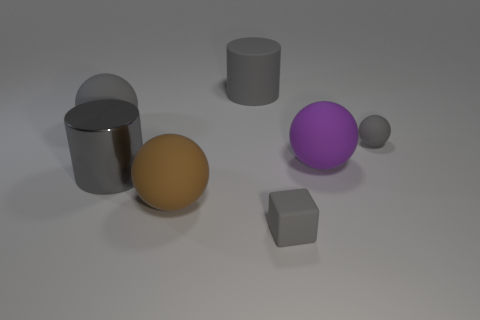There is a ball that is both on the left side of the cube and behind the large brown thing; how big is it?
Ensure brevity in your answer.  Large. The small ball that is the same material as the brown thing is what color?
Provide a succinct answer. Gray. What number of gray objects have the same material as the brown thing?
Offer a very short reply. 4. Are there the same number of gray cylinders that are to the left of the block and small things to the left of the gray rubber cylinder?
Offer a terse response. No. There is a large brown rubber thing; is its shape the same as the large thing to the right of the tiny rubber cube?
Provide a succinct answer. Yes. There is a tiny ball that is the same color as the tiny rubber cube; what is it made of?
Provide a succinct answer. Rubber. Is the small sphere made of the same material as the gray sphere left of the gray rubber cylinder?
Provide a succinct answer. Yes. The large rubber object right of the gray rubber thing behind the large matte object to the left of the large shiny thing is what color?
Provide a short and direct response. Purple. Do the tiny ball and the large cylinder that is in front of the gray rubber cylinder have the same color?
Your answer should be very brief. Yes. The big shiny cylinder is what color?
Your answer should be very brief. Gray. 